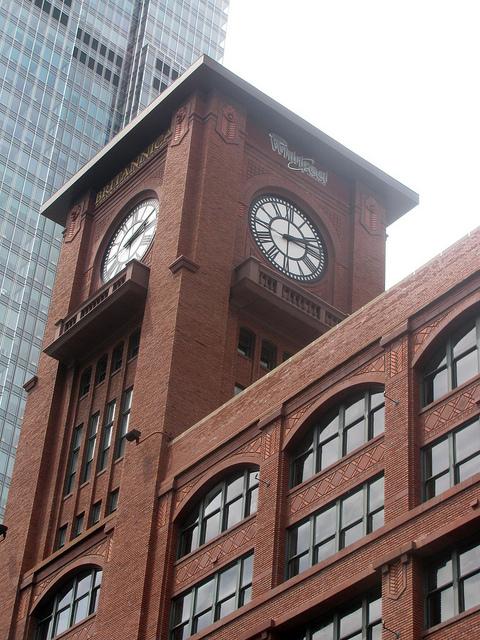How many clocks are there?
Short answer required. 2. What the written above the clock?
Short answer required. Whirlpool. Is there a statue on top of the clock tower?
Give a very brief answer. No. What is written above the clock facing left?
Be succinct. Whirlpool. What time is on the clock?
Write a very short answer. 2:15. Is that a modern building?
Concise answer only. Yes. Could the time be 2:15 PM?
Quick response, please. Yes. What color is the clock?
Be succinct. White. Is there a balcony on the building?
Short answer required. Yes. What time does this clock have?
Short answer required. 2:15. What do the letters say on the tower?
Answer briefly. Whirlpool. How many windows on the brown building?
Write a very short answer. 9. How many clock faces do you see?
Keep it brief. 2. 